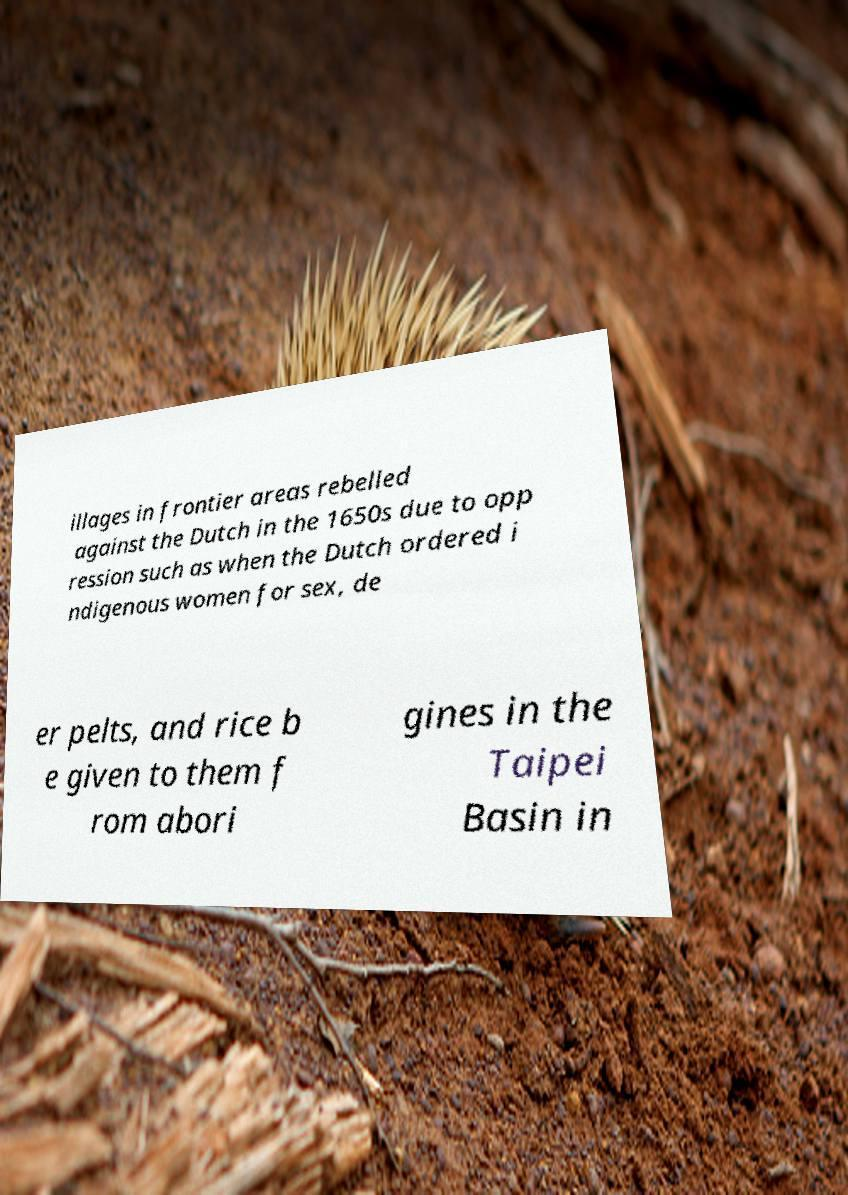Could you extract and type out the text from this image? illages in frontier areas rebelled against the Dutch in the 1650s due to opp ression such as when the Dutch ordered i ndigenous women for sex, de er pelts, and rice b e given to them f rom abori gines in the Taipei Basin in 